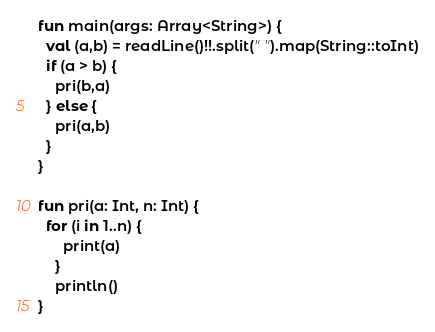<code> <loc_0><loc_0><loc_500><loc_500><_Kotlin_>fun main(args: Array<String>) {
  val (a,b) = readLine()!!.split(" ").map(String::toInt)
  if (a > b) {
    pri(b,a)
  } else {
    pri(a,b)
  }
}
  
fun pri(a: Int, n: Int) {
  for (i in 1..n) {
      print(a) 
    }
    println()
}</code> 